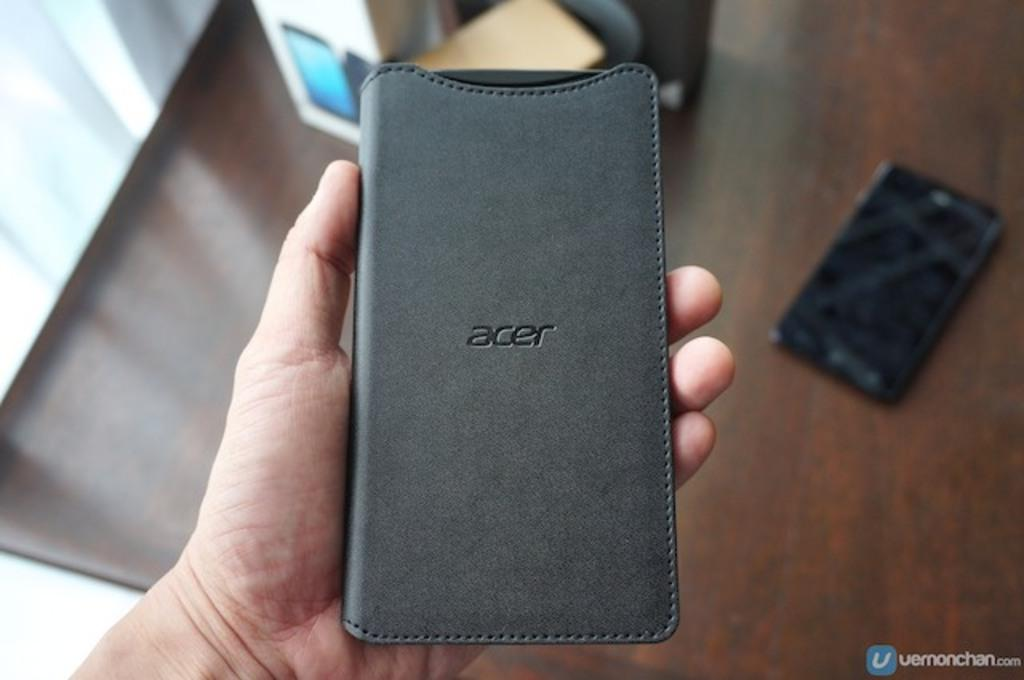<image>
Create a compact narrative representing the image presented. A hand holding a gray ACER phone case 